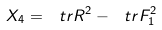<formula> <loc_0><loc_0><loc_500><loc_500>X _ { 4 } = \ t r R ^ { 2 } - \ t r F _ { 1 } ^ { 2 }</formula> 